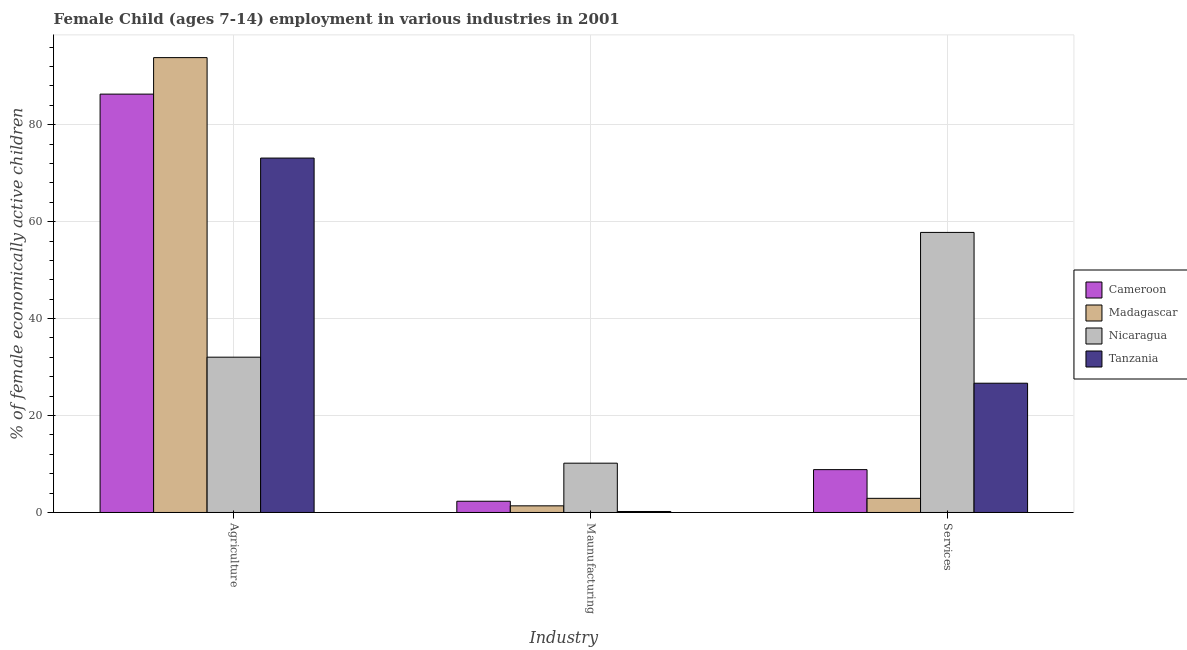How many different coloured bars are there?
Make the answer very short. 4. How many groups of bars are there?
Offer a terse response. 3. How many bars are there on the 1st tick from the left?
Make the answer very short. 4. What is the label of the 3rd group of bars from the left?
Provide a short and direct response. Services. What is the percentage of economically active children in manufacturing in Nicaragua?
Offer a terse response. 10.17. Across all countries, what is the maximum percentage of economically active children in manufacturing?
Keep it short and to the point. 10.17. Across all countries, what is the minimum percentage of economically active children in agriculture?
Make the answer very short. 32.04. In which country was the percentage of economically active children in agriculture maximum?
Offer a terse response. Madagascar. In which country was the percentage of economically active children in manufacturing minimum?
Offer a very short reply. Tanzania. What is the total percentage of economically active children in manufacturing in the graph?
Offer a terse response. 14.07. What is the difference between the percentage of economically active children in services in Nicaragua and that in Tanzania?
Your answer should be compact. 31.11. What is the difference between the percentage of economically active children in agriculture in Cameroon and the percentage of economically active children in services in Nicaragua?
Keep it short and to the point. 28.53. What is the average percentage of economically active children in manufacturing per country?
Ensure brevity in your answer.  3.52. What is the difference between the percentage of economically active children in services and percentage of economically active children in manufacturing in Nicaragua?
Your answer should be compact. 47.61. What is the ratio of the percentage of economically active children in agriculture in Tanzania to that in Madagascar?
Make the answer very short. 0.78. What is the difference between the highest and the second highest percentage of economically active children in agriculture?
Your answer should be compact. 7.53. What is the difference between the highest and the lowest percentage of economically active children in agriculture?
Your answer should be compact. 61.81. Is the sum of the percentage of economically active children in services in Tanzania and Cameroon greater than the maximum percentage of economically active children in manufacturing across all countries?
Your answer should be compact. Yes. What does the 4th bar from the left in Services represents?
Your answer should be compact. Tanzania. What does the 1st bar from the right in Services represents?
Give a very brief answer. Tanzania. Are all the bars in the graph horizontal?
Keep it short and to the point. No. Are the values on the major ticks of Y-axis written in scientific E-notation?
Your answer should be compact. No. Does the graph contain grids?
Provide a short and direct response. Yes. How many legend labels are there?
Provide a short and direct response. 4. How are the legend labels stacked?
Keep it short and to the point. Vertical. What is the title of the graph?
Your answer should be compact. Female Child (ages 7-14) employment in various industries in 2001. Does "American Samoa" appear as one of the legend labels in the graph?
Your answer should be very brief. No. What is the label or title of the X-axis?
Your answer should be compact. Industry. What is the label or title of the Y-axis?
Keep it short and to the point. % of female economically active children. What is the % of female economically active children in Cameroon in Agriculture?
Ensure brevity in your answer.  86.32. What is the % of female economically active children in Madagascar in Agriculture?
Give a very brief answer. 93.85. What is the % of female economically active children in Nicaragua in Agriculture?
Provide a short and direct response. 32.04. What is the % of female economically active children of Tanzania in Agriculture?
Your answer should be very brief. 73.12. What is the % of female economically active children in Cameroon in Maunufacturing?
Offer a very short reply. 2.32. What is the % of female economically active children in Madagascar in Maunufacturing?
Make the answer very short. 1.37. What is the % of female economically active children in Nicaragua in Maunufacturing?
Give a very brief answer. 10.17. What is the % of female economically active children in Tanzania in Maunufacturing?
Ensure brevity in your answer.  0.2. What is the % of female economically active children of Cameroon in Services?
Give a very brief answer. 8.84. What is the % of female economically active children of Madagascar in Services?
Offer a very short reply. 2.92. What is the % of female economically active children of Nicaragua in Services?
Offer a very short reply. 57.79. What is the % of female economically active children of Tanzania in Services?
Your answer should be very brief. 26.67. Across all Industry, what is the maximum % of female economically active children of Cameroon?
Your answer should be compact. 86.32. Across all Industry, what is the maximum % of female economically active children of Madagascar?
Provide a short and direct response. 93.85. Across all Industry, what is the maximum % of female economically active children of Nicaragua?
Offer a very short reply. 57.79. Across all Industry, what is the maximum % of female economically active children of Tanzania?
Ensure brevity in your answer.  73.12. Across all Industry, what is the minimum % of female economically active children of Cameroon?
Ensure brevity in your answer.  2.32. Across all Industry, what is the minimum % of female economically active children in Madagascar?
Provide a short and direct response. 1.37. Across all Industry, what is the minimum % of female economically active children of Nicaragua?
Provide a succinct answer. 10.17. Across all Industry, what is the minimum % of female economically active children in Tanzania?
Your answer should be compact. 0.2. What is the total % of female economically active children of Cameroon in the graph?
Your answer should be compact. 97.48. What is the total % of female economically active children of Madagascar in the graph?
Provide a succinct answer. 98.14. What is the difference between the % of female economically active children of Cameroon in Agriculture and that in Maunufacturing?
Keep it short and to the point. 84. What is the difference between the % of female economically active children in Madagascar in Agriculture and that in Maunufacturing?
Ensure brevity in your answer.  92.48. What is the difference between the % of female economically active children in Nicaragua in Agriculture and that in Maunufacturing?
Your answer should be compact. 21.87. What is the difference between the % of female economically active children in Tanzania in Agriculture and that in Maunufacturing?
Keep it short and to the point. 72.92. What is the difference between the % of female economically active children in Cameroon in Agriculture and that in Services?
Provide a succinct answer. 77.48. What is the difference between the % of female economically active children of Madagascar in Agriculture and that in Services?
Give a very brief answer. 90.93. What is the difference between the % of female economically active children of Nicaragua in Agriculture and that in Services?
Ensure brevity in your answer.  -25.74. What is the difference between the % of female economically active children of Tanzania in Agriculture and that in Services?
Provide a short and direct response. 46.45. What is the difference between the % of female economically active children in Cameroon in Maunufacturing and that in Services?
Your answer should be very brief. -6.52. What is the difference between the % of female economically active children in Madagascar in Maunufacturing and that in Services?
Ensure brevity in your answer.  -1.55. What is the difference between the % of female economically active children in Nicaragua in Maunufacturing and that in Services?
Your answer should be very brief. -47.61. What is the difference between the % of female economically active children in Tanzania in Maunufacturing and that in Services?
Provide a succinct answer. -26.47. What is the difference between the % of female economically active children in Cameroon in Agriculture and the % of female economically active children in Madagascar in Maunufacturing?
Offer a terse response. 84.95. What is the difference between the % of female economically active children of Cameroon in Agriculture and the % of female economically active children of Nicaragua in Maunufacturing?
Your answer should be very brief. 76.15. What is the difference between the % of female economically active children in Cameroon in Agriculture and the % of female economically active children in Tanzania in Maunufacturing?
Your response must be concise. 86.12. What is the difference between the % of female economically active children in Madagascar in Agriculture and the % of female economically active children in Nicaragua in Maunufacturing?
Your answer should be compact. 83.68. What is the difference between the % of female economically active children in Madagascar in Agriculture and the % of female economically active children in Tanzania in Maunufacturing?
Give a very brief answer. 93.65. What is the difference between the % of female economically active children in Nicaragua in Agriculture and the % of female economically active children in Tanzania in Maunufacturing?
Ensure brevity in your answer.  31.84. What is the difference between the % of female economically active children in Cameroon in Agriculture and the % of female economically active children in Madagascar in Services?
Offer a terse response. 83.4. What is the difference between the % of female economically active children in Cameroon in Agriculture and the % of female economically active children in Nicaragua in Services?
Make the answer very short. 28.53. What is the difference between the % of female economically active children of Cameroon in Agriculture and the % of female economically active children of Tanzania in Services?
Offer a very short reply. 59.65. What is the difference between the % of female economically active children of Madagascar in Agriculture and the % of female economically active children of Nicaragua in Services?
Give a very brief answer. 36.06. What is the difference between the % of female economically active children in Madagascar in Agriculture and the % of female economically active children in Tanzania in Services?
Provide a succinct answer. 67.18. What is the difference between the % of female economically active children in Nicaragua in Agriculture and the % of female economically active children in Tanzania in Services?
Keep it short and to the point. 5.37. What is the difference between the % of female economically active children of Cameroon in Maunufacturing and the % of female economically active children of Madagascar in Services?
Your answer should be compact. -0.6. What is the difference between the % of female economically active children of Cameroon in Maunufacturing and the % of female economically active children of Nicaragua in Services?
Your response must be concise. -55.47. What is the difference between the % of female economically active children of Cameroon in Maunufacturing and the % of female economically active children of Tanzania in Services?
Ensure brevity in your answer.  -24.35. What is the difference between the % of female economically active children of Madagascar in Maunufacturing and the % of female economically active children of Nicaragua in Services?
Make the answer very short. -56.42. What is the difference between the % of female economically active children in Madagascar in Maunufacturing and the % of female economically active children in Tanzania in Services?
Your answer should be very brief. -25.3. What is the difference between the % of female economically active children in Nicaragua in Maunufacturing and the % of female economically active children in Tanzania in Services?
Offer a very short reply. -16.5. What is the average % of female economically active children in Cameroon per Industry?
Your answer should be very brief. 32.49. What is the average % of female economically active children of Madagascar per Industry?
Your response must be concise. 32.71. What is the average % of female economically active children of Nicaragua per Industry?
Ensure brevity in your answer.  33.33. What is the average % of female economically active children of Tanzania per Industry?
Give a very brief answer. 33.33. What is the difference between the % of female economically active children of Cameroon and % of female economically active children of Madagascar in Agriculture?
Ensure brevity in your answer.  -7.53. What is the difference between the % of female economically active children of Cameroon and % of female economically active children of Nicaragua in Agriculture?
Provide a short and direct response. 54.28. What is the difference between the % of female economically active children in Cameroon and % of female economically active children in Tanzania in Agriculture?
Your response must be concise. 13.2. What is the difference between the % of female economically active children in Madagascar and % of female economically active children in Nicaragua in Agriculture?
Offer a terse response. 61.81. What is the difference between the % of female economically active children in Madagascar and % of female economically active children in Tanzania in Agriculture?
Give a very brief answer. 20.73. What is the difference between the % of female economically active children in Nicaragua and % of female economically active children in Tanzania in Agriculture?
Ensure brevity in your answer.  -41.08. What is the difference between the % of female economically active children of Cameroon and % of female economically active children of Nicaragua in Maunufacturing?
Your answer should be compact. -7.85. What is the difference between the % of female economically active children in Cameroon and % of female economically active children in Tanzania in Maunufacturing?
Keep it short and to the point. 2.12. What is the difference between the % of female economically active children of Madagascar and % of female economically active children of Nicaragua in Maunufacturing?
Offer a terse response. -8.8. What is the difference between the % of female economically active children in Madagascar and % of female economically active children in Tanzania in Maunufacturing?
Your answer should be compact. 1.17. What is the difference between the % of female economically active children in Nicaragua and % of female economically active children in Tanzania in Maunufacturing?
Provide a short and direct response. 9.97. What is the difference between the % of female economically active children in Cameroon and % of female economically active children in Madagascar in Services?
Keep it short and to the point. 5.92. What is the difference between the % of female economically active children of Cameroon and % of female economically active children of Nicaragua in Services?
Offer a terse response. -48.95. What is the difference between the % of female economically active children of Cameroon and % of female economically active children of Tanzania in Services?
Provide a short and direct response. -17.83. What is the difference between the % of female economically active children of Madagascar and % of female economically active children of Nicaragua in Services?
Keep it short and to the point. -54.87. What is the difference between the % of female economically active children of Madagascar and % of female economically active children of Tanzania in Services?
Provide a short and direct response. -23.75. What is the difference between the % of female economically active children in Nicaragua and % of female economically active children in Tanzania in Services?
Offer a very short reply. 31.11. What is the ratio of the % of female economically active children of Cameroon in Agriculture to that in Maunufacturing?
Provide a succinct answer. 37.21. What is the ratio of the % of female economically active children in Madagascar in Agriculture to that in Maunufacturing?
Ensure brevity in your answer.  68.5. What is the ratio of the % of female economically active children in Nicaragua in Agriculture to that in Maunufacturing?
Offer a terse response. 3.15. What is the ratio of the % of female economically active children in Tanzania in Agriculture to that in Maunufacturing?
Provide a short and direct response. 360.16. What is the ratio of the % of female economically active children in Cameroon in Agriculture to that in Services?
Make the answer very short. 9.76. What is the ratio of the % of female economically active children of Madagascar in Agriculture to that in Services?
Ensure brevity in your answer.  32.14. What is the ratio of the % of female economically active children of Nicaragua in Agriculture to that in Services?
Your answer should be compact. 0.55. What is the ratio of the % of female economically active children of Tanzania in Agriculture to that in Services?
Offer a very short reply. 2.74. What is the ratio of the % of female economically active children of Cameroon in Maunufacturing to that in Services?
Your response must be concise. 0.26. What is the ratio of the % of female economically active children in Madagascar in Maunufacturing to that in Services?
Give a very brief answer. 0.47. What is the ratio of the % of female economically active children in Nicaragua in Maunufacturing to that in Services?
Provide a short and direct response. 0.18. What is the ratio of the % of female economically active children of Tanzania in Maunufacturing to that in Services?
Make the answer very short. 0.01. What is the difference between the highest and the second highest % of female economically active children in Cameroon?
Your response must be concise. 77.48. What is the difference between the highest and the second highest % of female economically active children of Madagascar?
Give a very brief answer. 90.93. What is the difference between the highest and the second highest % of female economically active children in Nicaragua?
Offer a terse response. 25.74. What is the difference between the highest and the second highest % of female economically active children of Tanzania?
Make the answer very short. 46.45. What is the difference between the highest and the lowest % of female economically active children of Cameroon?
Your answer should be compact. 84. What is the difference between the highest and the lowest % of female economically active children in Madagascar?
Provide a succinct answer. 92.48. What is the difference between the highest and the lowest % of female economically active children of Nicaragua?
Give a very brief answer. 47.61. What is the difference between the highest and the lowest % of female economically active children in Tanzania?
Your answer should be very brief. 72.92. 